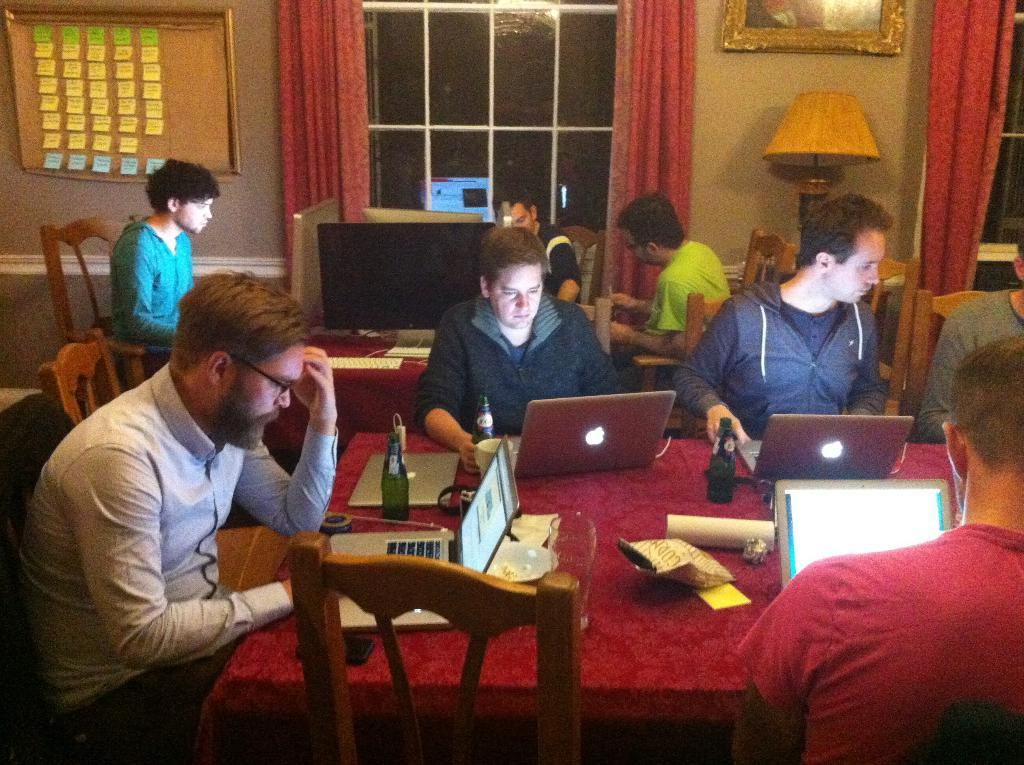How many people are in the image? There is a group of persons in the image. What are the persons doing in the image? The persons are working on laptops. What can be seen on the table in the image? There are bottles on the table. What type of snack is present in the image? There is popcorn in the image. What is visible at the top of the image? There is a window at the top of the image. What type of window treatment is associated with the window? There is a red color curtain associated with the window. Where is the crib located in the image? There is no crib present in the image. What type of thread is being used by the persons in the image? The persons in the image are working on laptops, and there is no mention of thread in the provided facts. 